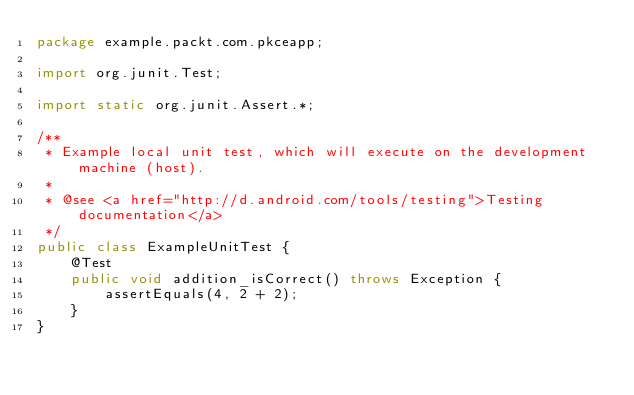<code> <loc_0><loc_0><loc_500><loc_500><_Java_>package example.packt.com.pkceapp;

import org.junit.Test;

import static org.junit.Assert.*;

/**
 * Example local unit test, which will execute on the development machine (host).
 *
 * @see <a href="http://d.android.com/tools/testing">Testing documentation</a>
 */
public class ExampleUnitTest {
    @Test
    public void addition_isCorrect() throws Exception {
        assertEquals(4, 2 + 2);
    }
}</code> 